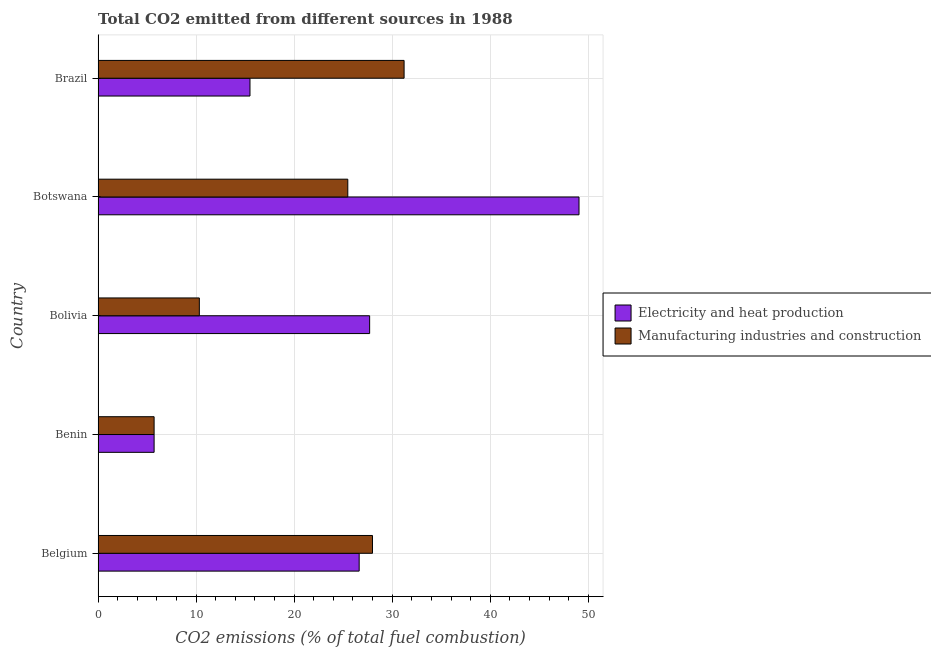How many different coloured bars are there?
Ensure brevity in your answer.  2. Are the number of bars per tick equal to the number of legend labels?
Your answer should be very brief. Yes. Are the number of bars on each tick of the Y-axis equal?
Your response must be concise. Yes. What is the label of the 4th group of bars from the top?
Your answer should be compact. Benin. In how many cases, is the number of bars for a given country not equal to the number of legend labels?
Give a very brief answer. 0. What is the co2 emissions due to manufacturing industries in Brazil?
Give a very brief answer. 31.21. Across all countries, what is the maximum co2 emissions due to electricity and heat production?
Your response must be concise. 49.06. Across all countries, what is the minimum co2 emissions due to electricity and heat production?
Offer a terse response. 5.71. In which country was the co2 emissions due to manufacturing industries maximum?
Give a very brief answer. Brazil. In which country was the co2 emissions due to manufacturing industries minimum?
Offer a very short reply. Benin. What is the total co2 emissions due to manufacturing industries in the graph?
Your answer should be compact. 100.72. What is the difference between the co2 emissions due to electricity and heat production in Belgium and that in Botswana?
Offer a very short reply. -22.42. What is the difference between the co2 emissions due to manufacturing industries in Brazil and the co2 emissions due to electricity and heat production in Bolivia?
Your answer should be very brief. 3.52. What is the average co2 emissions due to electricity and heat production per country?
Provide a succinct answer. 24.92. What is the difference between the co2 emissions due to manufacturing industries and co2 emissions due to electricity and heat production in Botswana?
Give a very brief answer. -23.59. In how many countries, is the co2 emissions due to electricity and heat production greater than 38 %?
Your answer should be compact. 1. What is the ratio of the co2 emissions due to electricity and heat production in Belgium to that in Botswana?
Your answer should be compact. 0.54. Is the co2 emissions due to electricity and heat production in Belgium less than that in Benin?
Offer a terse response. No. Is the difference between the co2 emissions due to electricity and heat production in Benin and Botswana greater than the difference between the co2 emissions due to manufacturing industries in Benin and Botswana?
Offer a terse response. No. What is the difference between the highest and the second highest co2 emissions due to manufacturing industries?
Offer a very short reply. 3.23. Is the sum of the co2 emissions due to manufacturing industries in Benin and Botswana greater than the maximum co2 emissions due to electricity and heat production across all countries?
Offer a terse response. No. What does the 1st bar from the top in Belgium represents?
Your answer should be compact. Manufacturing industries and construction. What does the 1st bar from the bottom in Botswana represents?
Ensure brevity in your answer.  Electricity and heat production. Are all the bars in the graph horizontal?
Keep it short and to the point. Yes. Are the values on the major ticks of X-axis written in scientific E-notation?
Your answer should be very brief. No. Does the graph contain any zero values?
Give a very brief answer. No. What is the title of the graph?
Your answer should be compact. Total CO2 emitted from different sources in 1988. What is the label or title of the X-axis?
Provide a short and direct response. CO2 emissions (% of total fuel combustion). What is the CO2 emissions (% of total fuel combustion) in Electricity and heat production in Belgium?
Ensure brevity in your answer.  26.63. What is the CO2 emissions (% of total fuel combustion) of Manufacturing industries and construction in Belgium?
Give a very brief answer. 27.99. What is the CO2 emissions (% of total fuel combustion) in Electricity and heat production in Benin?
Your answer should be very brief. 5.71. What is the CO2 emissions (% of total fuel combustion) of Manufacturing industries and construction in Benin?
Provide a succinct answer. 5.71. What is the CO2 emissions (% of total fuel combustion) in Electricity and heat production in Bolivia?
Your answer should be very brief. 27.7. What is the CO2 emissions (% of total fuel combustion) in Manufacturing industries and construction in Bolivia?
Make the answer very short. 10.33. What is the CO2 emissions (% of total fuel combustion) in Electricity and heat production in Botswana?
Make the answer very short. 49.06. What is the CO2 emissions (% of total fuel combustion) in Manufacturing industries and construction in Botswana?
Provide a succinct answer. 25.47. What is the CO2 emissions (% of total fuel combustion) of Electricity and heat production in Brazil?
Your answer should be compact. 15.49. What is the CO2 emissions (% of total fuel combustion) in Manufacturing industries and construction in Brazil?
Provide a succinct answer. 31.21. Across all countries, what is the maximum CO2 emissions (% of total fuel combustion) of Electricity and heat production?
Your response must be concise. 49.06. Across all countries, what is the maximum CO2 emissions (% of total fuel combustion) in Manufacturing industries and construction?
Ensure brevity in your answer.  31.21. Across all countries, what is the minimum CO2 emissions (% of total fuel combustion) in Electricity and heat production?
Keep it short and to the point. 5.71. Across all countries, what is the minimum CO2 emissions (% of total fuel combustion) in Manufacturing industries and construction?
Your answer should be compact. 5.71. What is the total CO2 emissions (% of total fuel combustion) in Electricity and heat production in the graph?
Offer a very short reply. 124.6. What is the total CO2 emissions (% of total fuel combustion) of Manufacturing industries and construction in the graph?
Make the answer very short. 100.72. What is the difference between the CO2 emissions (% of total fuel combustion) in Electricity and heat production in Belgium and that in Benin?
Offer a terse response. 20.92. What is the difference between the CO2 emissions (% of total fuel combustion) in Manufacturing industries and construction in Belgium and that in Benin?
Provide a short and direct response. 22.28. What is the difference between the CO2 emissions (% of total fuel combustion) in Electricity and heat production in Belgium and that in Bolivia?
Provide a short and direct response. -1.07. What is the difference between the CO2 emissions (% of total fuel combustion) in Manufacturing industries and construction in Belgium and that in Bolivia?
Your answer should be very brief. 17.66. What is the difference between the CO2 emissions (% of total fuel combustion) of Electricity and heat production in Belgium and that in Botswana?
Offer a very short reply. -22.42. What is the difference between the CO2 emissions (% of total fuel combustion) in Manufacturing industries and construction in Belgium and that in Botswana?
Keep it short and to the point. 2.52. What is the difference between the CO2 emissions (% of total fuel combustion) in Electricity and heat production in Belgium and that in Brazil?
Your answer should be compact. 11.14. What is the difference between the CO2 emissions (% of total fuel combustion) of Manufacturing industries and construction in Belgium and that in Brazil?
Provide a short and direct response. -3.23. What is the difference between the CO2 emissions (% of total fuel combustion) of Electricity and heat production in Benin and that in Bolivia?
Make the answer very short. -21.99. What is the difference between the CO2 emissions (% of total fuel combustion) in Manufacturing industries and construction in Benin and that in Bolivia?
Keep it short and to the point. -4.61. What is the difference between the CO2 emissions (% of total fuel combustion) in Electricity and heat production in Benin and that in Botswana?
Make the answer very short. -43.34. What is the difference between the CO2 emissions (% of total fuel combustion) of Manufacturing industries and construction in Benin and that in Botswana?
Give a very brief answer. -19.76. What is the difference between the CO2 emissions (% of total fuel combustion) of Electricity and heat production in Benin and that in Brazil?
Make the answer very short. -9.78. What is the difference between the CO2 emissions (% of total fuel combustion) of Manufacturing industries and construction in Benin and that in Brazil?
Provide a short and direct response. -25.5. What is the difference between the CO2 emissions (% of total fuel combustion) in Electricity and heat production in Bolivia and that in Botswana?
Keep it short and to the point. -21.36. What is the difference between the CO2 emissions (% of total fuel combustion) in Manufacturing industries and construction in Bolivia and that in Botswana?
Keep it short and to the point. -15.14. What is the difference between the CO2 emissions (% of total fuel combustion) of Electricity and heat production in Bolivia and that in Brazil?
Offer a very short reply. 12.2. What is the difference between the CO2 emissions (% of total fuel combustion) in Manufacturing industries and construction in Bolivia and that in Brazil?
Offer a terse response. -20.89. What is the difference between the CO2 emissions (% of total fuel combustion) of Electricity and heat production in Botswana and that in Brazil?
Your answer should be very brief. 33.56. What is the difference between the CO2 emissions (% of total fuel combustion) of Manufacturing industries and construction in Botswana and that in Brazil?
Your answer should be compact. -5.74. What is the difference between the CO2 emissions (% of total fuel combustion) of Electricity and heat production in Belgium and the CO2 emissions (% of total fuel combustion) of Manufacturing industries and construction in Benin?
Offer a very short reply. 20.92. What is the difference between the CO2 emissions (% of total fuel combustion) in Electricity and heat production in Belgium and the CO2 emissions (% of total fuel combustion) in Manufacturing industries and construction in Bolivia?
Make the answer very short. 16.3. What is the difference between the CO2 emissions (% of total fuel combustion) of Electricity and heat production in Belgium and the CO2 emissions (% of total fuel combustion) of Manufacturing industries and construction in Botswana?
Make the answer very short. 1.16. What is the difference between the CO2 emissions (% of total fuel combustion) in Electricity and heat production in Belgium and the CO2 emissions (% of total fuel combustion) in Manufacturing industries and construction in Brazil?
Provide a short and direct response. -4.58. What is the difference between the CO2 emissions (% of total fuel combustion) of Electricity and heat production in Benin and the CO2 emissions (% of total fuel combustion) of Manufacturing industries and construction in Bolivia?
Give a very brief answer. -4.61. What is the difference between the CO2 emissions (% of total fuel combustion) in Electricity and heat production in Benin and the CO2 emissions (% of total fuel combustion) in Manufacturing industries and construction in Botswana?
Provide a succinct answer. -19.76. What is the difference between the CO2 emissions (% of total fuel combustion) of Electricity and heat production in Benin and the CO2 emissions (% of total fuel combustion) of Manufacturing industries and construction in Brazil?
Ensure brevity in your answer.  -25.5. What is the difference between the CO2 emissions (% of total fuel combustion) of Electricity and heat production in Bolivia and the CO2 emissions (% of total fuel combustion) of Manufacturing industries and construction in Botswana?
Make the answer very short. 2.23. What is the difference between the CO2 emissions (% of total fuel combustion) in Electricity and heat production in Bolivia and the CO2 emissions (% of total fuel combustion) in Manufacturing industries and construction in Brazil?
Offer a very short reply. -3.52. What is the difference between the CO2 emissions (% of total fuel combustion) in Electricity and heat production in Botswana and the CO2 emissions (% of total fuel combustion) in Manufacturing industries and construction in Brazil?
Your answer should be compact. 17.84. What is the average CO2 emissions (% of total fuel combustion) in Electricity and heat production per country?
Offer a very short reply. 24.92. What is the average CO2 emissions (% of total fuel combustion) in Manufacturing industries and construction per country?
Provide a short and direct response. 20.14. What is the difference between the CO2 emissions (% of total fuel combustion) in Electricity and heat production and CO2 emissions (% of total fuel combustion) in Manufacturing industries and construction in Belgium?
Provide a succinct answer. -1.36. What is the difference between the CO2 emissions (% of total fuel combustion) of Electricity and heat production and CO2 emissions (% of total fuel combustion) of Manufacturing industries and construction in Benin?
Offer a very short reply. 0. What is the difference between the CO2 emissions (% of total fuel combustion) in Electricity and heat production and CO2 emissions (% of total fuel combustion) in Manufacturing industries and construction in Bolivia?
Keep it short and to the point. 17.37. What is the difference between the CO2 emissions (% of total fuel combustion) of Electricity and heat production and CO2 emissions (% of total fuel combustion) of Manufacturing industries and construction in Botswana?
Offer a terse response. 23.58. What is the difference between the CO2 emissions (% of total fuel combustion) in Electricity and heat production and CO2 emissions (% of total fuel combustion) in Manufacturing industries and construction in Brazil?
Make the answer very short. -15.72. What is the ratio of the CO2 emissions (% of total fuel combustion) in Electricity and heat production in Belgium to that in Benin?
Offer a very short reply. 4.66. What is the ratio of the CO2 emissions (% of total fuel combustion) of Manufacturing industries and construction in Belgium to that in Benin?
Offer a very short reply. 4.9. What is the ratio of the CO2 emissions (% of total fuel combustion) of Electricity and heat production in Belgium to that in Bolivia?
Ensure brevity in your answer.  0.96. What is the ratio of the CO2 emissions (% of total fuel combustion) in Manufacturing industries and construction in Belgium to that in Bolivia?
Your response must be concise. 2.71. What is the ratio of the CO2 emissions (% of total fuel combustion) in Electricity and heat production in Belgium to that in Botswana?
Ensure brevity in your answer.  0.54. What is the ratio of the CO2 emissions (% of total fuel combustion) of Manufacturing industries and construction in Belgium to that in Botswana?
Provide a succinct answer. 1.1. What is the ratio of the CO2 emissions (% of total fuel combustion) of Electricity and heat production in Belgium to that in Brazil?
Give a very brief answer. 1.72. What is the ratio of the CO2 emissions (% of total fuel combustion) in Manufacturing industries and construction in Belgium to that in Brazil?
Offer a very short reply. 0.9. What is the ratio of the CO2 emissions (% of total fuel combustion) in Electricity and heat production in Benin to that in Bolivia?
Ensure brevity in your answer.  0.21. What is the ratio of the CO2 emissions (% of total fuel combustion) of Manufacturing industries and construction in Benin to that in Bolivia?
Your answer should be very brief. 0.55. What is the ratio of the CO2 emissions (% of total fuel combustion) in Electricity and heat production in Benin to that in Botswana?
Provide a short and direct response. 0.12. What is the ratio of the CO2 emissions (% of total fuel combustion) of Manufacturing industries and construction in Benin to that in Botswana?
Offer a very short reply. 0.22. What is the ratio of the CO2 emissions (% of total fuel combustion) of Electricity and heat production in Benin to that in Brazil?
Offer a very short reply. 0.37. What is the ratio of the CO2 emissions (% of total fuel combustion) of Manufacturing industries and construction in Benin to that in Brazil?
Your answer should be compact. 0.18. What is the ratio of the CO2 emissions (% of total fuel combustion) in Electricity and heat production in Bolivia to that in Botswana?
Your answer should be compact. 0.56. What is the ratio of the CO2 emissions (% of total fuel combustion) of Manufacturing industries and construction in Bolivia to that in Botswana?
Make the answer very short. 0.41. What is the ratio of the CO2 emissions (% of total fuel combustion) in Electricity and heat production in Bolivia to that in Brazil?
Provide a short and direct response. 1.79. What is the ratio of the CO2 emissions (% of total fuel combustion) of Manufacturing industries and construction in Bolivia to that in Brazil?
Your answer should be very brief. 0.33. What is the ratio of the CO2 emissions (% of total fuel combustion) of Electricity and heat production in Botswana to that in Brazil?
Provide a short and direct response. 3.17. What is the ratio of the CO2 emissions (% of total fuel combustion) in Manufacturing industries and construction in Botswana to that in Brazil?
Ensure brevity in your answer.  0.82. What is the difference between the highest and the second highest CO2 emissions (% of total fuel combustion) in Electricity and heat production?
Your answer should be compact. 21.36. What is the difference between the highest and the second highest CO2 emissions (% of total fuel combustion) in Manufacturing industries and construction?
Offer a terse response. 3.23. What is the difference between the highest and the lowest CO2 emissions (% of total fuel combustion) in Electricity and heat production?
Make the answer very short. 43.34. What is the difference between the highest and the lowest CO2 emissions (% of total fuel combustion) in Manufacturing industries and construction?
Provide a succinct answer. 25.5. 